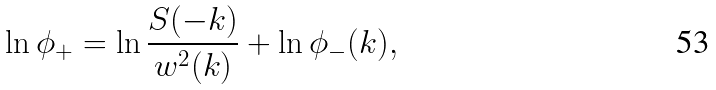<formula> <loc_0><loc_0><loc_500><loc_500>\ln \phi _ { + } = \ln \frac { S ( - k ) } { w ^ { 2 } ( k ) } + \ln \phi _ { - } ( k ) ,</formula> 